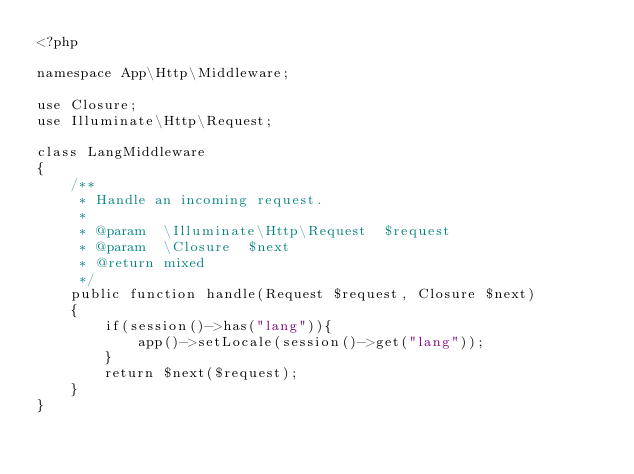<code> <loc_0><loc_0><loc_500><loc_500><_PHP_><?php

namespace App\Http\Middleware;

use Closure;
use Illuminate\Http\Request;

class LangMiddleware
{
    /**
     * Handle an incoming request.
     *
     * @param  \Illuminate\Http\Request  $request
     * @param  \Closure  $next
     * @return mixed
     */
    public function handle(Request $request, Closure $next)
    {
        if(session()->has("lang")){
            app()->setLocale(session()->get("lang"));
        }
        return $next($request);
    }
}
</code> 